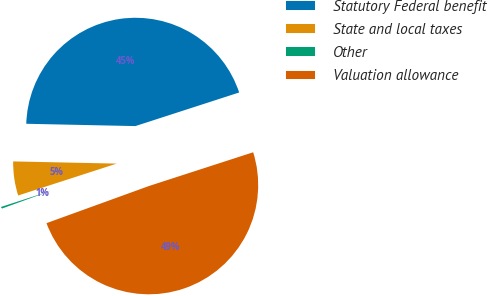Convert chart to OTSL. <chart><loc_0><loc_0><loc_500><loc_500><pie_chart><fcel>Statutory Federal benefit<fcel>State and local taxes<fcel>Other<fcel>Valuation allowance<nl><fcel>44.68%<fcel>5.32%<fcel>0.55%<fcel>49.45%<nl></chart> 